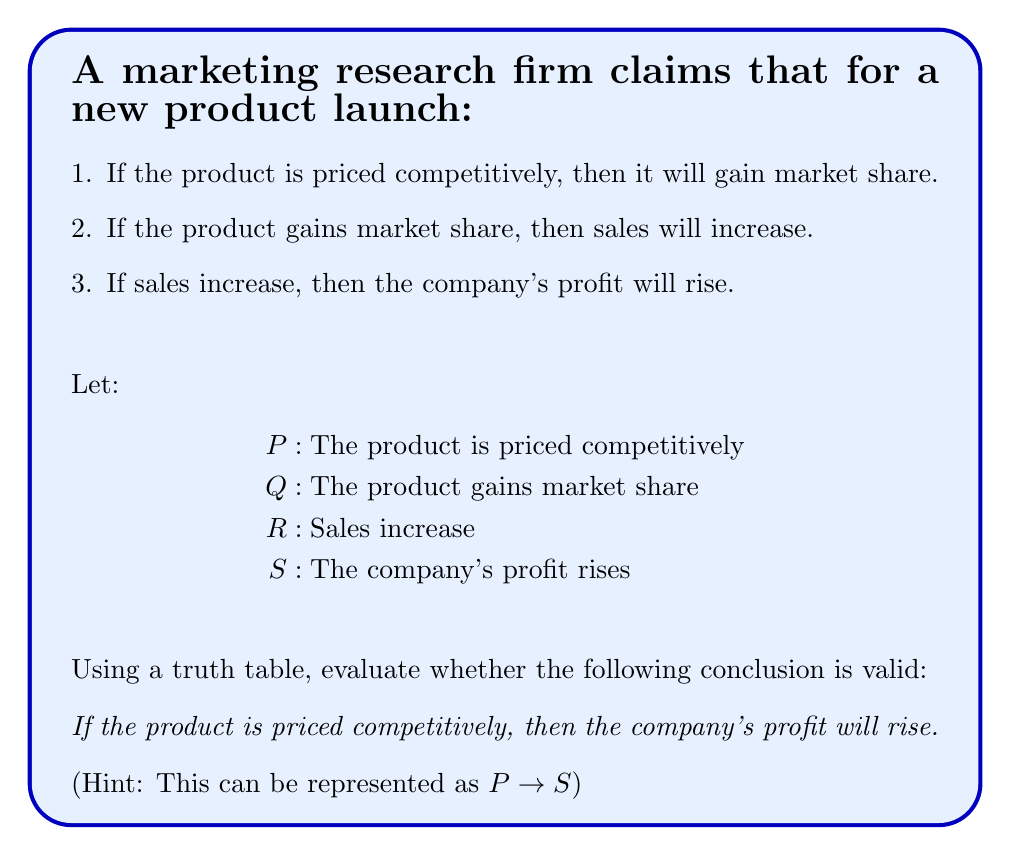Could you help me with this problem? To evaluate the validity of the conclusion using a truth table, we need to:

1. Construct a truth table for all given premises.
2. Evaluate the conclusion based on the premises.

Step 1: Construct the truth table

We have four variables (P, Q, R, S), so our truth table will have $2^4 = 16$ rows.

$$
\begin{array}{|c|c|c|c|c|c|c|c|}
\hline
P & Q & R & S & P \rightarrow Q & Q \rightarrow R & R \rightarrow S & P \rightarrow S \\
\hline
T & T & T & T & T & T & T & T \\
T & T & T & F & T & T & F & F \\
T & T & F & T & T & F & T & T \\
T & T & F & F & T & F & T & F \\
T & F & T & T & F & T & T & T \\
T & F & T & F & F & T & F & F \\
T & F & F & T & F & T & T & T \\
T & F & F & F & F & T & T & F \\
F & T & T & T & T & T & T & T \\
F & T & T & F & T & T & F & T \\
F & T & F & T & T & F & T & T \\
F & T & F & F & T & F & T & T \\
F & F & T & T & T & T & T & T \\
F & F & T & F & T & T & F & T \\
F & F & F & T & T & T & T & T \\
F & F & F & F & T & T & T & T \\
\hline
\end{array}
$$

Step 2: Evaluate the conclusion

For the conclusion to be valid, $P \rightarrow S$ must be true whenever all premises $(P \rightarrow Q, Q \rightarrow R, R \rightarrow S)$ are true.

Looking at the truth table, we can see that there are cases where all premises are true, but $P \rightarrow S$ is false. Specifically, in the second row of the table:

$$
\begin{array}{|c|c|c|c|c|c|c|c|}
\hline
P & Q & R & S & P \rightarrow Q & Q \rightarrow R & R \rightarrow S & P \rightarrow S \\
\hline
T & T & T & F & T & T & F & F \\
\hline
\end{array}
$$

In this case, all premises are true, but the conclusion $(P \rightarrow S)$ is false.

Therefore, the conclusion is not valid based on the given premises.
Answer: The conclusion is invalid. 